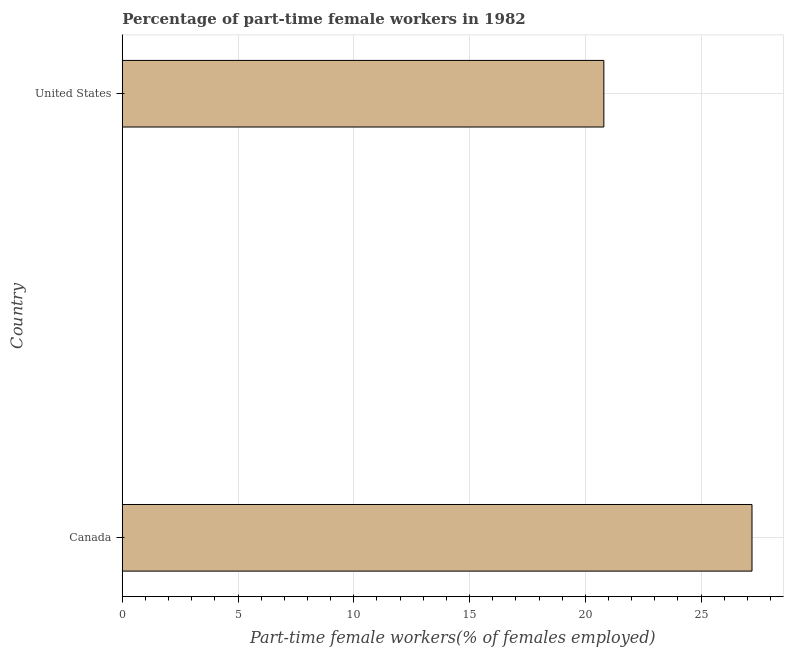What is the title of the graph?
Your answer should be compact. Percentage of part-time female workers in 1982. What is the label or title of the X-axis?
Give a very brief answer. Part-time female workers(% of females employed). What is the label or title of the Y-axis?
Your answer should be very brief. Country. What is the percentage of part-time female workers in Canada?
Your response must be concise. 27.2. Across all countries, what is the maximum percentage of part-time female workers?
Offer a very short reply. 27.2. Across all countries, what is the minimum percentage of part-time female workers?
Provide a succinct answer. 20.8. In which country was the percentage of part-time female workers maximum?
Make the answer very short. Canada. In which country was the percentage of part-time female workers minimum?
Your response must be concise. United States. What is the ratio of the percentage of part-time female workers in Canada to that in United States?
Keep it short and to the point. 1.31. In how many countries, is the percentage of part-time female workers greater than the average percentage of part-time female workers taken over all countries?
Offer a very short reply. 1. What is the difference between two consecutive major ticks on the X-axis?
Offer a terse response. 5. Are the values on the major ticks of X-axis written in scientific E-notation?
Offer a terse response. No. What is the Part-time female workers(% of females employed) of Canada?
Keep it short and to the point. 27.2. What is the Part-time female workers(% of females employed) of United States?
Keep it short and to the point. 20.8. What is the difference between the Part-time female workers(% of females employed) in Canada and United States?
Give a very brief answer. 6.4. What is the ratio of the Part-time female workers(% of females employed) in Canada to that in United States?
Offer a very short reply. 1.31. 